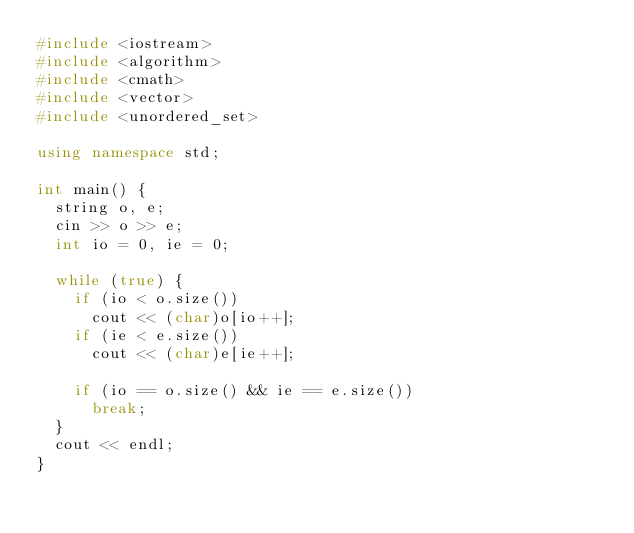Convert code to text. <code><loc_0><loc_0><loc_500><loc_500><_C++_>#include <iostream>
#include <algorithm>
#include <cmath>
#include <vector>
#include <unordered_set>

using namespace std;

int main() {
  string o, e;
  cin >> o >> e;
  int io = 0, ie = 0;

  while (true) {
    if (io < o.size())
      cout << (char)o[io++];
    if (ie < e.size())
      cout << (char)e[ie++];

    if (io == o.size() && ie == e.size())
      break;
  }
  cout << endl;
}
</code> 